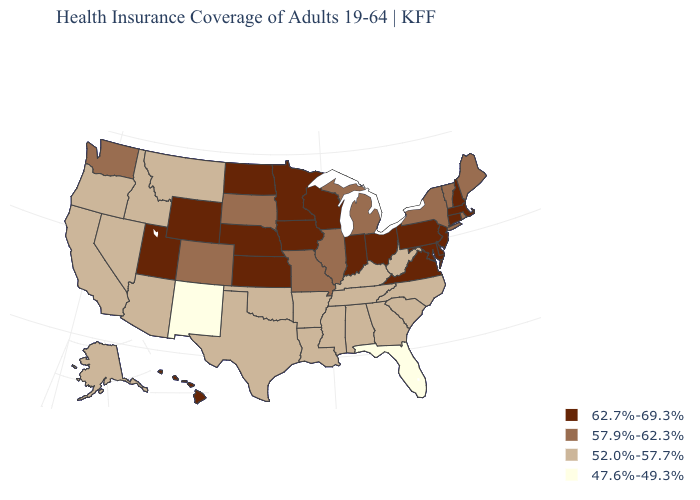Which states have the highest value in the USA?
Keep it brief. Connecticut, Delaware, Hawaii, Indiana, Iowa, Kansas, Maryland, Massachusetts, Minnesota, Nebraska, New Hampshire, New Jersey, North Dakota, Ohio, Pennsylvania, Utah, Virginia, Wisconsin, Wyoming. What is the value of Alaska?
Write a very short answer. 52.0%-57.7%. What is the highest value in the MidWest ?
Quick response, please. 62.7%-69.3%. What is the lowest value in states that border New Jersey?
Keep it brief. 57.9%-62.3%. Does the map have missing data?
Give a very brief answer. No. What is the value of Iowa?
Write a very short answer. 62.7%-69.3%. Name the states that have a value in the range 52.0%-57.7%?
Be succinct. Alabama, Alaska, Arizona, Arkansas, California, Georgia, Idaho, Kentucky, Louisiana, Mississippi, Montana, Nevada, North Carolina, Oklahoma, Oregon, South Carolina, Tennessee, Texas, West Virginia. Which states have the highest value in the USA?
Answer briefly. Connecticut, Delaware, Hawaii, Indiana, Iowa, Kansas, Maryland, Massachusetts, Minnesota, Nebraska, New Hampshire, New Jersey, North Dakota, Ohio, Pennsylvania, Utah, Virginia, Wisconsin, Wyoming. What is the lowest value in states that border Florida?
Concise answer only. 52.0%-57.7%. What is the highest value in the USA?
Keep it brief. 62.7%-69.3%. What is the value of Missouri?
Keep it brief. 57.9%-62.3%. Among the states that border New Mexico , does Colorado have the lowest value?
Keep it brief. No. Name the states that have a value in the range 47.6%-49.3%?
Keep it brief. Florida, New Mexico. Among the states that border South Carolina , which have the highest value?
Answer briefly. Georgia, North Carolina. What is the lowest value in the USA?
Short answer required. 47.6%-49.3%. 